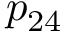<formula> <loc_0><loc_0><loc_500><loc_500>p _ { 2 4 }</formula> 